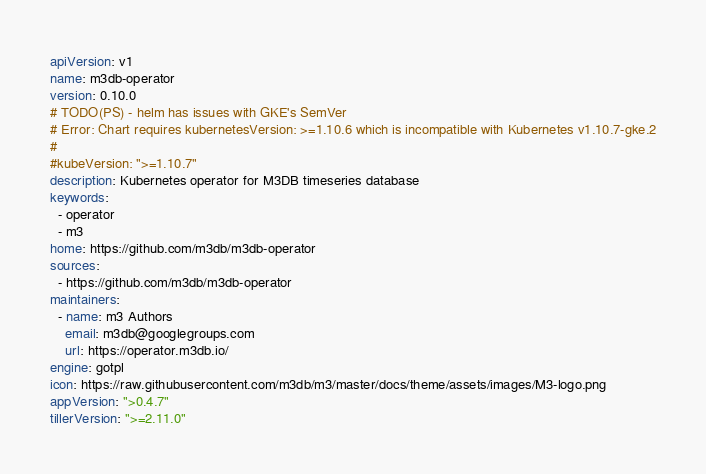Convert code to text. <code><loc_0><loc_0><loc_500><loc_500><_YAML_>apiVersion: v1
name: m3db-operator
version: 0.10.0
# TODO(PS) - helm has issues with GKE's SemVer
# Error: Chart requires kubernetesVersion: >=1.10.6 which is incompatible with Kubernetes v1.10.7-gke.2
#
#kubeVersion: ">=1.10.7"
description: Kubernetes operator for M3DB timeseries database
keywords:
  - operator
  - m3
home: https://github.com/m3db/m3db-operator
sources:
  - https://github.com/m3db/m3db-operator
maintainers:
  - name: m3 Authors
    email: m3db@googlegroups.com
    url: https://operator.m3db.io/
engine: gotpl
icon: https://raw.githubusercontent.com/m3db/m3/master/docs/theme/assets/images/M3-logo.png
appVersion: ">0.4.7"
tillerVersion: ">=2.11.0"
</code> 